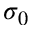<formula> <loc_0><loc_0><loc_500><loc_500>\sigma _ { 0 }</formula> 